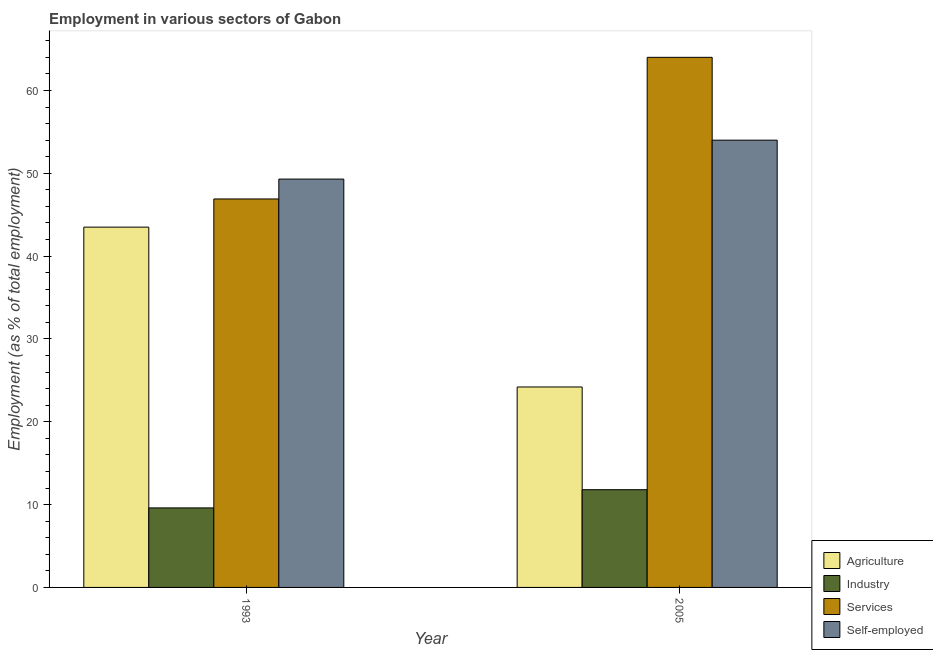How many different coloured bars are there?
Provide a succinct answer. 4. How many groups of bars are there?
Your response must be concise. 2. How many bars are there on the 2nd tick from the left?
Provide a succinct answer. 4. What is the label of the 2nd group of bars from the left?
Ensure brevity in your answer.  2005. What is the percentage of workers in agriculture in 2005?
Your answer should be very brief. 24.2. Across all years, what is the minimum percentage of workers in industry?
Ensure brevity in your answer.  9.6. What is the total percentage of workers in services in the graph?
Your response must be concise. 110.9. What is the difference between the percentage of self employed workers in 1993 and that in 2005?
Offer a very short reply. -4.7. What is the difference between the percentage of workers in services in 2005 and the percentage of self employed workers in 1993?
Provide a succinct answer. 17.1. What is the average percentage of workers in agriculture per year?
Give a very brief answer. 33.85. What is the ratio of the percentage of workers in agriculture in 1993 to that in 2005?
Offer a very short reply. 1.8. Is the percentage of workers in industry in 1993 less than that in 2005?
Provide a short and direct response. Yes. Is it the case that in every year, the sum of the percentage of workers in industry and percentage of workers in services is greater than the sum of percentage of workers in agriculture and percentage of self employed workers?
Keep it short and to the point. Yes. What does the 3rd bar from the left in 1993 represents?
Provide a short and direct response. Services. What does the 4th bar from the right in 2005 represents?
Your answer should be compact. Agriculture. How many bars are there?
Your answer should be very brief. 8. Are all the bars in the graph horizontal?
Your answer should be compact. No. What is the difference between two consecutive major ticks on the Y-axis?
Your response must be concise. 10. Does the graph contain any zero values?
Offer a very short reply. No. What is the title of the graph?
Keep it short and to the point. Employment in various sectors of Gabon. Does "UNTA" appear as one of the legend labels in the graph?
Ensure brevity in your answer.  No. What is the label or title of the Y-axis?
Provide a short and direct response. Employment (as % of total employment). What is the Employment (as % of total employment) of Agriculture in 1993?
Keep it short and to the point. 43.5. What is the Employment (as % of total employment) of Industry in 1993?
Provide a short and direct response. 9.6. What is the Employment (as % of total employment) in Services in 1993?
Provide a short and direct response. 46.9. What is the Employment (as % of total employment) of Self-employed in 1993?
Provide a succinct answer. 49.3. What is the Employment (as % of total employment) in Agriculture in 2005?
Offer a very short reply. 24.2. What is the Employment (as % of total employment) of Industry in 2005?
Give a very brief answer. 11.8. What is the Employment (as % of total employment) in Self-employed in 2005?
Your answer should be compact. 54. Across all years, what is the maximum Employment (as % of total employment) of Agriculture?
Keep it short and to the point. 43.5. Across all years, what is the maximum Employment (as % of total employment) in Industry?
Your answer should be compact. 11.8. Across all years, what is the maximum Employment (as % of total employment) of Self-employed?
Offer a very short reply. 54. Across all years, what is the minimum Employment (as % of total employment) of Agriculture?
Your response must be concise. 24.2. Across all years, what is the minimum Employment (as % of total employment) in Industry?
Keep it short and to the point. 9.6. Across all years, what is the minimum Employment (as % of total employment) in Services?
Keep it short and to the point. 46.9. Across all years, what is the minimum Employment (as % of total employment) in Self-employed?
Give a very brief answer. 49.3. What is the total Employment (as % of total employment) of Agriculture in the graph?
Your answer should be very brief. 67.7. What is the total Employment (as % of total employment) of Industry in the graph?
Keep it short and to the point. 21.4. What is the total Employment (as % of total employment) of Services in the graph?
Provide a short and direct response. 110.9. What is the total Employment (as % of total employment) of Self-employed in the graph?
Provide a short and direct response. 103.3. What is the difference between the Employment (as % of total employment) of Agriculture in 1993 and that in 2005?
Offer a very short reply. 19.3. What is the difference between the Employment (as % of total employment) of Services in 1993 and that in 2005?
Keep it short and to the point. -17.1. What is the difference between the Employment (as % of total employment) of Agriculture in 1993 and the Employment (as % of total employment) of Industry in 2005?
Your answer should be very brief. 31.7. What is the difference between the Employment (as % of total employment) of Agriculture in 1993 and the Employment (as % of total employment) of Services in 2005?
Offer a very short reply. -20.5. What is the difference between the Employment (as % of total employment) in Industry in 1993 and the Employment (as % of total employment) in Services in 2005?
Your answer should be very brief. -54.4. What is the difference between the Employment (as % of total employment) of Industry in 1993 and the Employment (as % of total employment) of Self-employed in 2005?
Provide a short and direct response. -44.4. What is the difference between the Employment (as % of total employment) of Services in 1993 and the Employment (as % of total employment) of Self-employed in 2005?
Your response must be concise. -7.1. What is the average Employment (as % of total employment) of Agriculture per year?
Your answer should be compact. 33.85. What is the average Employment (as % of total employment) of Industry per year?
Keep it short and to the point. 10.7. What is the average Employment (as % of total employment) in Services per year?
Keep it short and to the point. 55.45. What is the average Employment (as % of total employment) in Self-employed per year?
Offer a very short reply. 51.65. In the year 1993, what is the difference between the Employment (as % of total employment) in Agriculture and Employment (as % of total employment) in Industry?
Your response must be concise. 33.9. In the year 1993, what is the difference between the Employment (as % of total employment) of Agriculture and Employment (as % of total employment) of Services?
Your answer should be compact. -3.4. In the year 1993, what is the difference between the Employment (as % of total employment) in Industry and Employment (as % of total employment) in Services?
Your response must be concise. -37.3. In the year 1993, what is the difference between the Employment (as % of total employment) in Industry and Employment (as % of total employment) in Self-employed?
Provide a short and direct response. -39.7. In the year 2005, what is the difference between the Employment (as % of total employment) in Agriculture and Employment (as % of total employment) in Industry?
Keep it short and to the point. 12.4. In the year 2005, what is the difference between the Employment (as % of total employment) of Agriculture and Employment (as % of total employment) of Services?
Give a very brief answer. -39.8. In the year 2005, what is the difference between the Employment (as % of total employment) in Agriculture and Employment (as % of total employment) in Self-employed?
Offer a very short reply. -29.8. In the year 2005, what is the difference between the Employment (as % of total employment) of Industry and Employment (as % of total employment) of Services?
Your response must be concise. -52.2. In the year 2005, what is the difference between the Employment (as % of total employment) in Industry and Employment (as % of total employment) in Self-employed?
Give a very brief answer. -42.2. What is the ratio of the Employment (as % of total employment) of Agriculture in 1993 to that in 2005?
Offer a terse response. 1.8. What is the ratio of the Employment (as % of total employment) in Industry in 1993 to that in 2005?
Your answer should be compact. 0.81. What is the ratio of the Employment (as % of total employment) of Services in 1993 to that in 2005?
Keep it short and to the point. 0.73. What is the ratio of the Employment (as % of total employment) of Self-employed in 1993 to that in 2005?
Ensure brevity in your answer.  0.91. What is the difference between the highest and the second highest Employment (as % of total employment) of Agriculture?
Your answer should be very brief. 19.3. What is the difference between the highest and the second highest Employment (as % of total employment) in Services?
Your answer should be very brief. 17.1. What is the difference between the highest and the lowest Employment (as % of total employment) in Agriculture?
Make the answer very short. 19.3. What is the difference between the highest and the lowest Employment (as % of total employment) in Self-employed?
Make the answer very short. 4.7. 